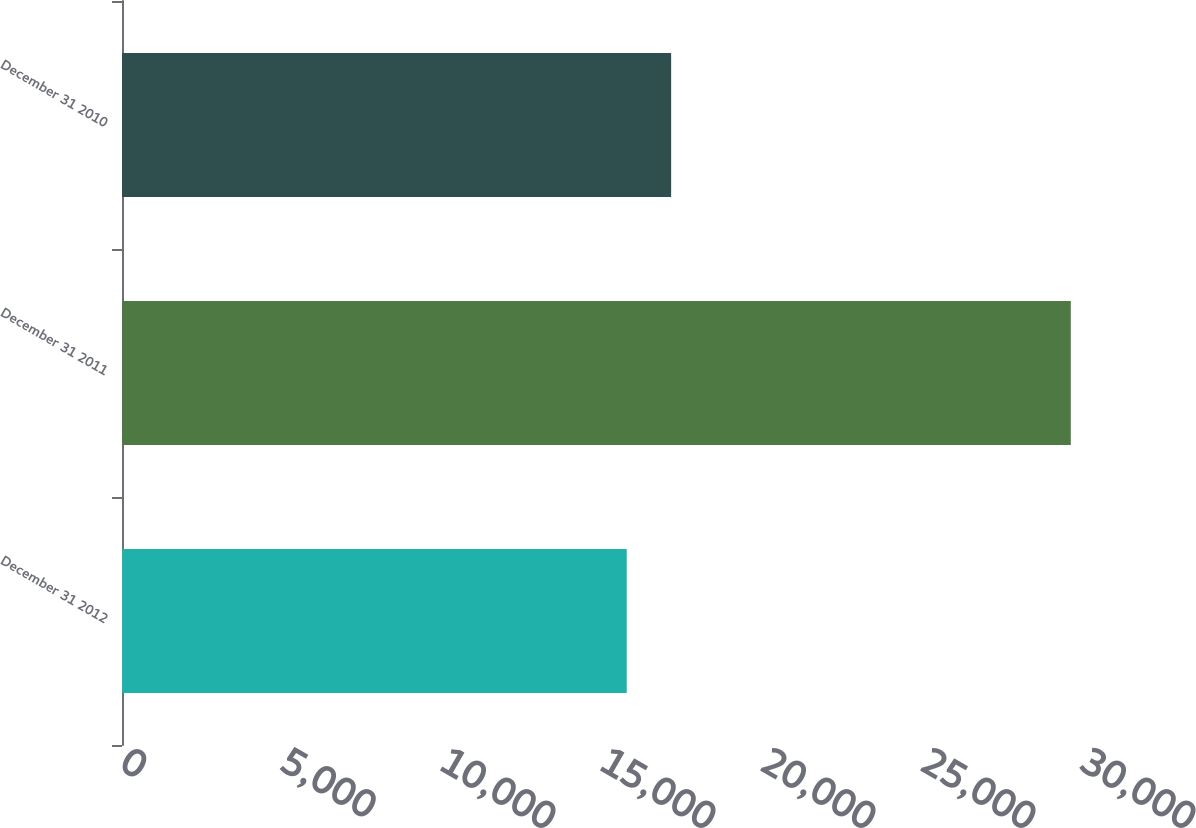Convert chart. <chart><loc_0><loc_0><loc_500><loc_500><bar_chart><fcel>December 31 2012<fcel>December 31 2011<fcel>December 31 2010<nl><fcel>15773<fcel>29650<fcel>17160.7<nl></chart> 